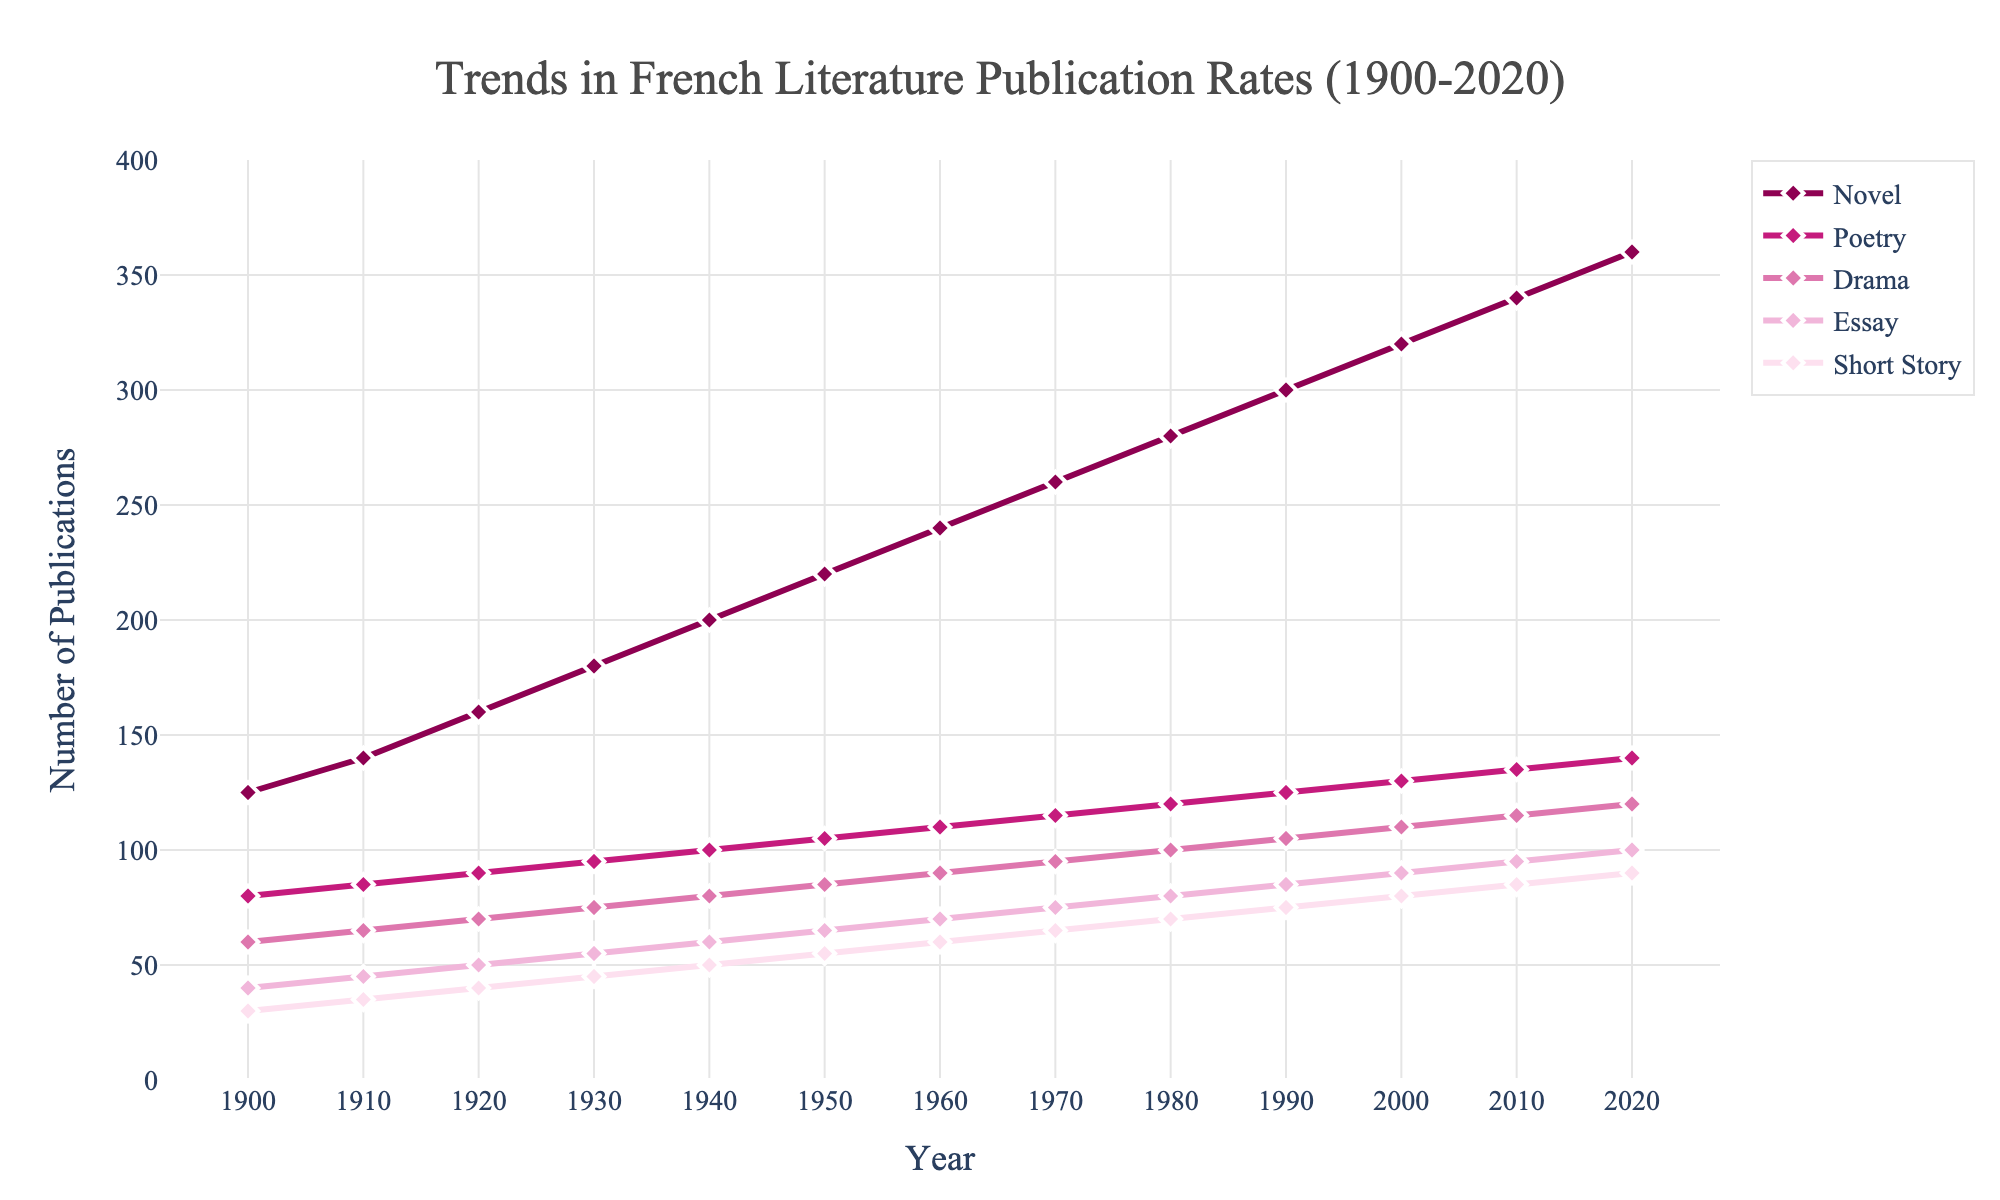What year saw the highest number of publications across all genres combined? To find the year with the highest number of publications, sum the values for all genres for each year and identify the year with the maximum sum. In 2020, the sum of publications is 360 (Novel) + 140 (Poetry) + 120 (Drama) + 100 (Essay) + 90 (Short Story) = 810, which is the highest.
Answer: 2020 Which genre experienced the smallest increase in publications from 1900 to 2020? Calculate the increase for each genre over the period by subtracting the 1900 value from the 2020 value. Drama increased by 120 - 60 = 60, which is the smallest increase among all genres.
Answer: Drama How do the publication rates of Novels and Poetry compare in 1930? Compare the number of publications for both Novels and Poetry in 1930. Novels had 180 publications, and Poetry had 95 publications.
Answer: Novels had significantly more publications compared to Poetry in 1930 Which genre saw the most consistent growth over the years? By observing the slopes of the lines, the genre with the most consistent growth is the one whose line is straight and steady. Novels show a fairly consistent rate of increase over the entire period.
Answer: Novels Between 1950 and 2000, did any genre see a decrease in publication rates? If so, which genre(s)? Check the values for each genre in 1950 and 2000 to see if any values went down. None of the genres saw a decrease; all saw increases.
Answer: No genre saw a decrease How did the publication rate of Short Stories change from 1900 to 2020? Subtract the 1900 value from the 2020 value for Short Stories. The number increased from 30 to 90, so the change is 90 - 30 = 60.
Answer: Increased by 60 In which decade did the genre of Essays see the most significant growth? Compare the growth for each decade by subtracting the start value of the decade from the end value. The biggest increase is from 1930 to 1940, where Essays grew from 55 to 60, an increase of 25.
Answer: 1930-1940 How do the overall publication trends of Essays and Short Stories contrast from 1900 to 2020? Visually inspect the trend lines for both genres. Both show a general upward trend, but Short Stories had a smaller absolute increase and a less steep slope compared to Essays.
Answer: Essays had a steeper growth trend than Short Stories Which genre's publication rates intersected with the rates of Drama the earliest? Look at the plot to identify intersections. The first intersection is between Drama and Poetry around 1950.
Answer: Poetry 